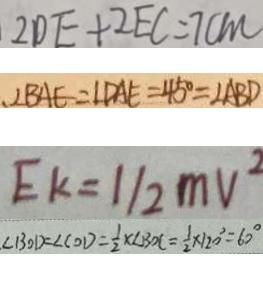Convert formula to latex. <formula><loc_0><loc_0><loc_500><loc_500>2 D E + 2 E C = 7 c m 
 、 \angle B A E = \angle D A E = 4 5 ^ { \circ } = \angle A B D 
 E k = 1 / 2 m v ^ { 2 } 
 \angle B O D = \angle C O D = \frac { 1 } { 2 } \times \angle B O C = \frac { 1 } { 2 } \times 1 2 0 ^ { \circ } = 6 0 ^ { \circ }</formula> 